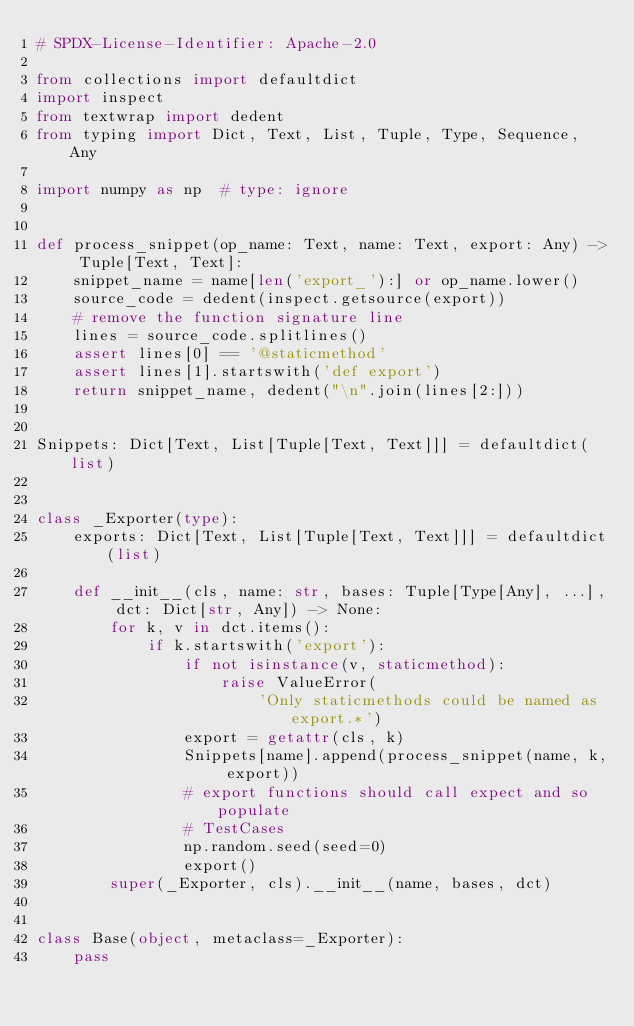Convert code to text. <code><loc_0><loc_0><loc_500><loc_500><_Python_># SPDX-License-Identifier: Apache-2.0

from collections import defaultdict
import inspect
from textwrap import dedent
from typing import Dict, Text, List, Tuple, Type, Sequence, Any

import numpy as np  # type: ignore


def process_snippet(op_name: Text, name: Text, export: Any) -> Tuple[Text, Text]:
    snippet_name = name[len('export_'):] or op_name.lower()
    source_code = dedent(inspect.getsource(export))
    # remove the function signature line
    lines = source_code.splitlines()
    assert lines[0] == '@staticmethod'
    assert lines[1].startswith('def export')
    return snippet_name, dedent("\n".join(lines[2:]))


Snippets: Dict[Text, List[Tuple[Text, Text]]] = defaultdict(list)


class _Exporter(type):
    exports: Dict[Text, List[Tuple[Text, Text]]] = defaultdict(list)

    def __init__(cls, name: str, bases: Tuple[Type[Any], ...], dct: Dict[str, Any]) -> None:
        for k, v in dct.items():
            if k.startswith('export'):
                if not isinstance(v, staticmethod):
                    raise ValueError(
                        'Only staticmethods could be named as export.*')
                export = getattr(cls, k)
                Snippets[name].append(process_snippet(name, k, export))
                # export functions should call expect and so populate
                # TestCases
                np.random.seed(seed=0)
                export()
        super(_Exporter, cls).__init__(name, bases, dct)


class Base(object, metaclass=_Exporter):
    pass
</code> 